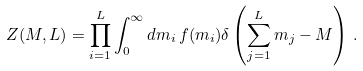Convert formula to latex. <formula><loc_0><loc_0><loc_500><loc_500>Z ( M , L ) = \prod _ { i = 1 } ^ { L } \int _ { 0 } ^ { \infty } d m _ { i } \, f ( m _ { i } ) \delta \left ( \sum _ { j = 1 } ^ { L } m _ { j } - M \right ) \, .</formula> 